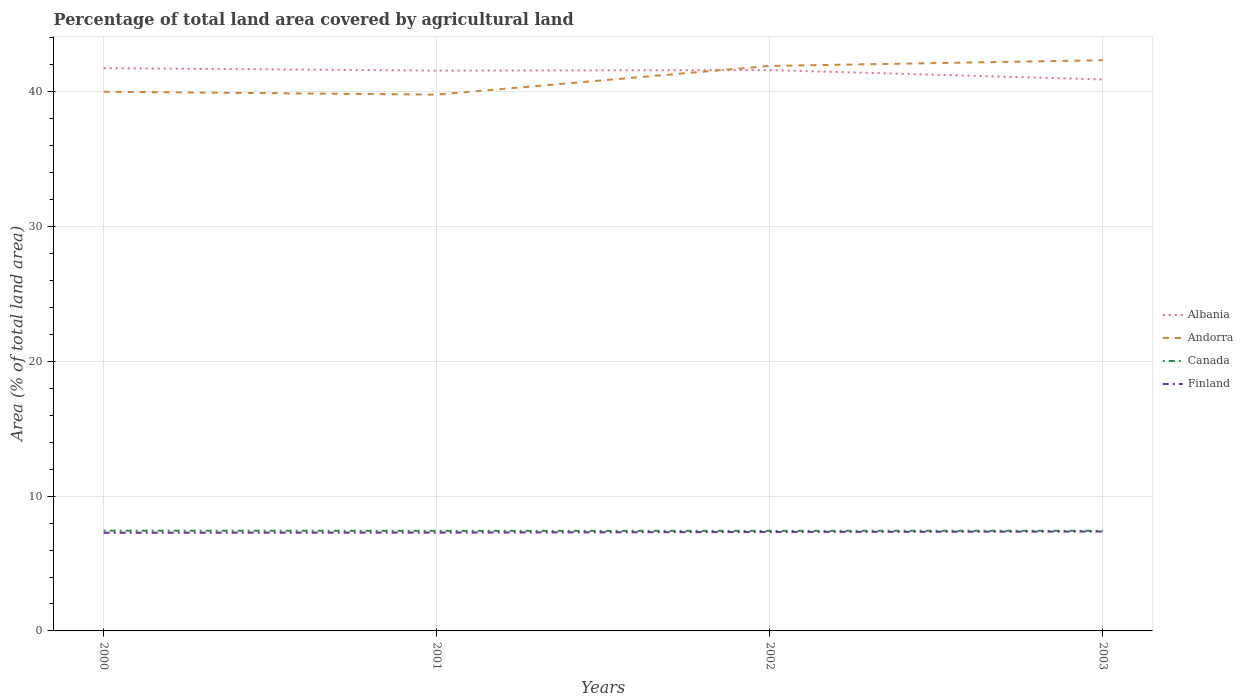Does the line corresponding to Finland intersect with the line corresponding to Canada?
Keep it short and to the point. No. Is the number of lines equal to the number of legend labels?
Provide a succinct answer. Yes. Across all years, what is the maximum percentage of agricultural land in Andorra?
Offer a terse response. 39.79. What is the total percentage of agricultural land in Finland in the graph?
Offer a terse response. -0.01. What is the difference between the highest and the second highest percentage of agricultural land in Andorra?
Give a very brief answer. 2.55. Is the percentage of agricultural land in Canada strictly greater than the percentage of agricultural land in Finland over the years?
Offer a terse response. No. How many lines are there?
Provide a succinct answer. 4. How many years are there in the graph?
Provide a short and direct response. 4. Are the values on the major ticks of Y-axis written in scientific E-notation?
Provide a succinct answer. No. Does the graph contain any zero values?
Your response must be concise. No. Where does the legend appear in the graph?
Keep it short and to the point. Center right. How many legend labels are there?
Provide a succinct answer. 4. How are the legend labels stacked?
Your response must be concise. Vertical. What is the title of the graph?
Provide a succinct answer. Percentage of total land area covered by agricultural land. What is the label or title of the X-axis?
Offer a very short reply. Years. What is the label or title of the Y-axis?
Offer a terse response. Area (% of total land area). What is the Area (% of total land area) in Albania in 2000?
Provide a short and direct response. 41.75. What is the Area (% of total land area) of Canada in 2000?
Your answer should be very brief. 7.44. What is the Area (% of total land area) in Finland in 2000?
Provide a short and direct response. 7.28. What is the Area (% of total land area) in Albania in 2001?
Offer a terse response. 41.57. What is the Area (% of total land area) of Andorra in 2001?
Ensure brevity in your answer.  39.79. What is the Area (% of total land area) of Canada in 2001?
Your response must be concise. 7.42. What is the Area (% of total land area) in Finland in 2001?
Make the answer very short. 7.3. What is the Area (% of total land area) of Albania in 2002?
Your answer should be compact. 41.61. What is the Area (% of total land area) of Andorra in 2002?
Offer a terse response. 41.91. What is the Area (% of total land area) of Canada in 2002?
Make the answer very short. 7.42. What is the Area (% of total land area) in Finland in 2002?
Your answer should be very brief. 7.34. What is the Area (% of total land area) of Albania in 2003?
Offer a very short reply. 40.91. What is the Area (% of total land area) of Andorra in 2003?
Your answer should be compact. 42.34. What is the Area (% of total land area) in Canada in 2003?
Provide a succinct answer. 7.43. What is the Area (% of total land area) in Finland in 2003?
Give a very brief answer. 7.37. Across all years, what is the maximum Area (% of total land area) of Albania?
Offer a terse response. 41.75. Across all years, what is the maximum Area (% of total land area) in Andorra?
Make the answer very short. 42.34. Across all years, what is the maximum Area (% of total land area) of Canada?
Keep it short and to the point. 7.44. Across all years, what is the maximum Area (% of total land area) in Finland?
Make the answer very short. 7.37. Across all years, what is the minimum Area (% of total land area) of Albania?
Your answer should be compact. 40.91. Across all years, what is the minimum Area (% of total land area) in Andorra?
Offer a terse response. 39.79. Across all years, what is the minimum Area (% of total land area) in Canada?
Your answer should be compact. 7.42. Across all years, what is the minimum Area (% of total land area) of Finland?
Make the answer very short. 7.28. What is the total Area (% of total land area) in Albania in the graph?
Provide a short and direct response. 165.84. What is the total Area (% of total land area) in Andorra in the graph?
Your answer should be very brief. 164.04. What is the total Area (% of total land area) of Canada in the graph?
Make the answer very short. 29.71. What is the total Area (% of total land area) in Finland in the graph?
Your answer should be very brief. 29.29. What is the difference between the Area (% of total land area) of Albania in 2000 and that in 2001?
Your response must be concise. 0.18. What is the difference between the Area (% of total land area) in Andorra in 2000 and that in 2001?
Offer a very short reply. 0.21. What is the difference between the Area (% of total land area) of Canada in 2000 and that in 2001?
Offer a terse response. 0.01. What is the difference between the Area (% of total land area) in Finland in 2000 and that in 2001?
Your answer should be compact. -0.01. What is the difference between the Area (% of total land area) of Albania in 2000 and that in 2002?
Your response must be concise. 0.15. What is the difference between the Area (% of total land area) in Andorra in 2000 and that in 2002?
Keep it short and to the point. -1.91. What is the difference between the Area (% of total land area) in Canada in 2000 and that in 2002?
Offer a very short reply. 0.01. What is the difference between the Area (% of total land area) of Finland in 2000 and that in 2002?
Make the answer very short. -0.06. What is the difference between the Area (% of total land area) in Albania in 2000 and that in 2003?
Offer a very short reply. 0.84. What is the difference between the Area (% of total land area) in Andorra in 2000 and that in 2003?
Provide a succinct answer. -2.34. What is the difference between the Area (% of total land area) of Canada in 2000 and that in 2003?
Your answer should be very brief. 0.01. What is the difference between the Area (% of total land area) in Finland in 2000 and that in 2003?
Provide a short and direct response. -0.09. What is the difference between the Area (% of total land area) in Albania in 2001 and that in 2002?
Keep it short and to the point. -0.04. What is the difference between the Area (% of total land area) in Andorra in 2001 and that in 2002?
Your answer should be compact. -2.13. What is the difference between the Area (% of total land area) in Canada in 2001 and that in 2002?
Make the answer very short. -0. What is the difference between the Area (% of total land area) in Finland in 2001 and that in 2002?
Provide a succinct answer. -0.05. What is the difference between the Area (% of total land area) of Albania in 2001 and that in 2003?
Provide a short and direct response. 0.66. What is the difference between the Area (% of total land area) in Andorra in 2001 and that in 2003?
Make the answer very short. -2.55. What is the difference between the Area (% of total land area) in Canada in 2001 and that in 2003?
Offer a terse response. -0. What is the difference between the Area (% of total land area) of Finland in 2001 and that in 2003?
Offer a terse response. -0.08. What is the difference between the Area (% of total land area) in Albania in 2002 and that in 2003?
Keep it short and to the point. 0.69. What is the difference between the Area (% of total land area) in Andorra in 2002 and that in 2003?
Your answer should be very brief. -0.43. What is the difference between the Area (% of total land area) of Canada in 2002 and that in 2003?
Your answer should be compact. -0. What is the difference between the Area (% of total land area) in Finland in 2002 and that in 2003?
Your answer should be compact. -0.03. What is the difference between the Area (% of total land area) of Albania in 2000 and the Area (% of total land area) of Andorra in 2001?
Offer a very short reply. 1.96. What is the difference between the Area (% of total land area) of Albania in 2000 and the Area (% of total land area) of Canada in 2001?
Give a very brief answer. 34.33. What is the difference between the Area (% of total land area) of Albania in 2000 and the Area (% of total land area) of Finland in 2001?
Provide a succinct answer. 34.46. What is the difference between the Area (% of total land area) of Andorra in 2000 and the Area (% of total land area) of Canada in 2001?
Your answer should be very brief. 32.58. What is the difference between the Area (% of total land area) of Andorra in 2000 and the Area (% of total land area) of Finland in 2001?
Your answer should be compact. 32.7. What is the difference between the Area (% of total land area) in Canada in 2000 and the Area (% of total land area) in Finland in 2001?
Keep it short and to the point. 0.14. What is the difference between the Area (% of total land area) of Albania in 2000 and the Area (% of total land area) of Andorra in 2002?
Your response must be concise. -0.16. What is the difference between the Area (% of total land area) of Albania in 2000 and the Area (% of total land area) of Canada in 2002?
Keep it short and to the point. 34.33. What is the difference between the Area (% of total land area) in Albania in 2000 and the Area (% of total land area) in Finland in 2002?
Make the answer very short. 34.41. What is the difference between the Area (% of total land area) of Andorra in 2000 and the Area (% of total land area) of Canada in 2002?
Ensure brevity in your answer.  32.58. What is the difference between the Area (% of total land area) in Andorra in 2000 and the Area (% of total land area) in Finland in 2002?
Your response must be concise. 32.66. What is the difference between the Area (% of total land area) of Canada in 2000 and the Area (% of total land area) of Finland in 2002?
Provide a short and direct response. 0.09. What is the difference between the Area (% of total land area) in Albania in 2000 and the Area (% of total land area) in Andorra in 2003?
Your answer should be compact. -0.59. What is the difference between the Area (% of total land area) of Albania in 2000 and the Area (% of total land area) of Canada in 2003?
Make the answer very short. 34.33. What is the difference between the Area (% of total land area) in Albania in 2000 and the Area (% of total land area) in Finland in 2003?
Keep it short and to the point. 34.38. What is the difference between the Area (% of total land area) in Andorra in 2000 and the Area (% of total land area) in Canada in 2003?
Keep it short and to the point. 32.57. What is the difference between the Area (% of total land area) in Andorra in 2000 and the Area (% of total land area) in Finland in 2003?
Keep it short and to the point. 32.63. What is the difference between the Area (% of total land area) of Canada in 2000 and the Area (% of total land area) of Finland in 2003?
Your answer should be compact. 0.06. What is the difference between the Area (% of total land area) in Albania in 2001 and the Area (% of total land area) in Andorra in 2002?
Give a very brief answer. -0.35. What is the difference between the Area (% of total land area) of Albania in 2001 and the Area (% of total land area) of Canada in 2002?
Provide a short and direct response. 34.14. What is the difference between the Area (% of total land area) in Albania in 2001 and the Area (% of total land area) in Finland in 2002?
Keep it short and to the point. 34.23. What is the difference between the Area (% of total land area) of Andorra in 2001 and the Area (% of total land area) of Canada in 2002?
Give a very brief answer. 32.36. What is the difference between the Area (% of total land area) of Andorra in 2001 and the Area (% of total land area) of Finland in 2002?
Your response must be concise. 32.45. What is the difference between the Area (% of total land area) of Canada in 2001 and the Area (% of total land area) of Finland in 2002?
Your response must be concise. 0.08. What is the difference between the Area (% of total land area) in Albania in 2001 and the Area (% of total land area) in Andorra in 2003?
Your answer should be compact. -0.77. What is the difference between the Area (% of total land area) of Albania in 2001 and the Area (% of total land area) of Canada in 2003?
Make the answer very short. 34.14. What is the difference between the Area (% of total land area) of Albania in 2001 and the Area (% of total land area) of Finland in 2003?
Give a very brief answer. 34.2. What is the difference between the Area (% of total land area) of Andorra in 2001 and the Area (% of total land area) of Canada in 2003?
Make the answer very short. 32.36. What is the difference between the Area (% of total land area) of Andorra in 2001 and the Area (% of total land area) of Finland in 2003?
Offer a very short reply. 32.41. What is the difference between the Area (% of total land area) in Canada in 2001 and the Area (% of total land area) in Finland in 2003?
Keep it short and to the point. 0.05. What is the difference between the Area (% of total land area) of Albania in 2002 and the Area (% of total land area) of Andorra in 2003?
Give a very brief answer. -0.73. What is the difference between the Area (% of total land area) of Albania in 2002 and the Area (% of total land area) of Canada in 2003?
Provide a succinct answer. 34.18. What is the difference between the Area (% of total land area) of Albania in 2002 and the Area (% of total land area) of Finland in 2003?
Keep it short and to the point. 34.23. What is the difference between the Area (% of total land area) of Andorra in 2002 and the Area (% of total land area) of Canada in 2003?
Offer a very short reply. 34.49. What is the difference between the Area (% of total land area) in Andorra in 2002 and the Area (% of total land area) in Finland in 2003?
Ensure brevity in your answer.  34.54. What is the difference between the Area (% of total land area) in Canada in 2002 and the Area (% of total land area) in Finland in 2003?
Your answer should be compact. 0.05. What is the average Area (% of total land area) in Albania per year?
Your answer should be very brief. 41.46. What is the average Area (% of total land area) of Andorra per year?
Make the answer very short. 41.01. What is the average Area (% of total land area) in Canada per year?
Provide a short and direct response. 7.43. What is the average Area (% of total land area) in Finland per year?
Your answer should be very brief. 7.32. In the year 2000, what is the difference between the Area (% of total land area) in Albania and Area (% of total land area) in Andorra?
Offer a terse response. 1.75. In the year 2000, what is the difference between the Area (% of total land area) in Albania and Area (% of total land area) in Canada?
Offer a terse response. 34.32. In the year 2000, what is the difference between the Area (% of total land area) of Albania and Area (% of total land area) of Finland?
Your answer should be compact. 34.47. In the year 2000, what is the difference between the Area (% of total land area) in Andorra and Area (% of total land area) in Canada?
Your response must be concise. 32.56. In the year 2000, what is the difference between the Area (% of total land area) in Andorra and Area (% of total land area) in Finland?
Make the answer very short. 32.72. In the year 2000, what is the difference between the Area (% of total land area) in Canada and Area (% of total land area) in Finland?
Give a very brief answer. 0.15. In the year 2001, what is the difference between the Area (% of total land area) of Albania and Area (% of total land area) of Andorra?
Offer a very short reply. 1.78. In the year 2001, what is the difference between the Area (% of total land area) of Albania and Area (% of total land area) of Canada?
Provide a short and direct response. 34.15. In the year 2001, what is the difference between the Area (% of total land area) of Albania and Area (% of total land area) of Finland?
Ensure brevity in your answer.  34.27. In the year 2001, what is the difference between the Area (% of total land area) in Andorra and Area (% of total land area) in Canada?
Offer a very short reply. 32.36. In the year 2001, what is the difference between the Area (% of total land area) in Andorra and Area (% of total land area) in Finland?
Keep it short and to the point. 32.49. In the year 2001, what is the difference between the Area (% of total land area) of Canada and Area (% of total land area) of Finland?
Your response must be concise. 0.13. In the year 2002, what is the difference between the Area (% of total land area) in Albania and Area (% of total land area) in Andorra?
Ensure brevity in your answer.  -0.31. In the year 2002, what is the difference between the Area (% of total land area) in Albania and Area (% of total land area) in Canada?
Give a very brief answer. 34.18. In the year 2002, what is the difference between the Area (% of total land area) of Albania and Area (% of total land area) of Finland?
Ensure brevity in your answer.  34.26. In the year 2002, what is the difference between the Area (% of total land area) in Andorra and Area (% of total land area) in Canada?
Your response must be concise. 34.49. In the year 2002, what is the difference between the Area (% of total land area) in Andorra and Area (% of total land area) in Finland?
Ensure brevity in your answer.  34.57. In the year 2002, what is the difference between the Area (% of total land area) of Canada and Area (% of total land area) of Finland?
Offer a terse response. 0.08. In the year 2003, what is the difference between the Area (% of total land area) in Albania and Area (% of total land area) in Andorra?
Your response must be concise. -1.43. In the year 2003, what is the difference between the Area (% of total land area) of Albania and Area (% of total land area) of Canada?
Provide a short and direct response. 33.49. In the year 2003, what is the difference between the Area (% of total land area) of Albania and Area (% of total land area) of Finland?
Provide a short and direct response. 33.54. In the year 2003, what is the difference between the Area (% of total land area) of Andorra and Area (% of total land area) of Canada?
Your answer should be very brief. 34.91. In the year 2003, what is the difference between the Area (% of total land area) in Andorra and Area (% of total land area) in Finland?
Provide a succinct answer. 34.97. In the year 2003, what is the difference between the Area (% of total land area) in Canada and Area (% of total land area) in Finland?
Provide a short and direct response. 0.05. What is the ratio of the Area (% of total land area) of Canada in 2000 to that in 2001?
Make the answer very short. 1. What is the ratio of the Area (% of total land area) in Finland in 2000 to that in 2001?
Your response must be concise. 1. What is the ratio of the Area (% of total land area) of Andorra in 2000 to that in 2002?
Your answer should be very brief. 0.95. What is the ratio of the Area (% of total land area) in Canada in 2000 to that in 2002?
Ensure brevity in your answer.  1. What is the ratio of the Area (% of total land area) of Albania in 2000 to that in 2003?
Offer a terse response. 1.02. What is the ratio of the Area (% of total land area) in Andorra in 2000 to that in 2003?
Provide a short and direct response. 0.94. What is the ratio of the Area (% of total land area) in Canada in 2000 to that in 2003?
Ensure brevity in your answer.  1. What is the ratio of the Area (% of total land area) of Finland in 2000 to that in 2003?
Your response must be concise. 0.99. What is the ratio of the Area (% of total land area) of Albania in 2001 to that in 2002?
Offer a very short reply. 1. What is the ratio of the Area (% of total land area) of Andorra in 2001 to that in 2002?
Your answer should be very brief. 0.95. What is the ratio of the Area (% of total land area) in Finland in 2001 to that in 2002?
Offer a terse response. 0.99. What is the ratio of the Area (% of total land area) in Albania in 2001 to that in 2003?
Make the answer very short. 1.02. What is the ratio of the Area (% of total land area) of Andorra in 2001 to that in 2003?
Ensure brevity in your answer.  0.94. What is the ratio of the Area (% of total land area) of Finland in 2001 to that in 2003?
Provide a succinct answer. 0.99. What is the ratio of the Area (% of total land area) of Albania in 2002 to that in 2003?
Your answer should be compact. 1.02. What is the difference between the highest and the second highest Area (% of total land area) in Albania?
Make the answer very short. 0.15. What is the difference between the highest and the second highest Area (% of total land area) in Andorra?
Give a very brief answer. 0.43. What is the difference between the highest and the second highest Area (% of total land area) of Canada?
Ensure brevity in your answer.  0.01. What is the difference between the highest and the second highest Area (% of total land area) of Finland?
Keep it short and to the point. 0.03. What is the difference between the highest and the lowest Area (% of total land area) in Albania?
Keep it short and to the point. 0.84. What is the difference between the highest and the lowest Area (% of total land area) in Andorra?
Ensure brevity in your answer.  2.55. What is the difference between the highest and the lowest Area (% of total land area) of Canada?
Provide a short and direct response. 0.01. What is the difference between the highest and the lowest Area (% of total land area) in Finland?
Give a very brief answer. 0.09. 